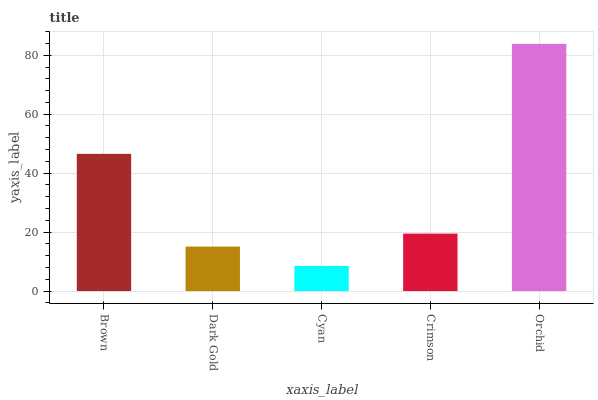Is Cyan the minimum?
Answer yes or no. Yes. Is Orchid the maximum?
Answer yes or no. Yes. Is Dark Gold the minimum?
Answer yes or no. No. Is Dark Gold the maximum?
Answer yes or no. No. Is Brown greater than Dark Gold?
Answer yes or no. Yes. Is Dark Gold less than Brown?
Answer yes or no. Yes. Is Dark Gold greater than Brown?
Answer yes or no. No. Is Brown less than Dark Gold?
Answer yes or no. No. Is Crimson the high median?
Answer yes or no. Yes. Is Crimson the low median?
Answer yes or no. Yes. Is Cyan the high median?
Answer yes or no. No. Is Cyan the low median?
Answer yes or no. No. 